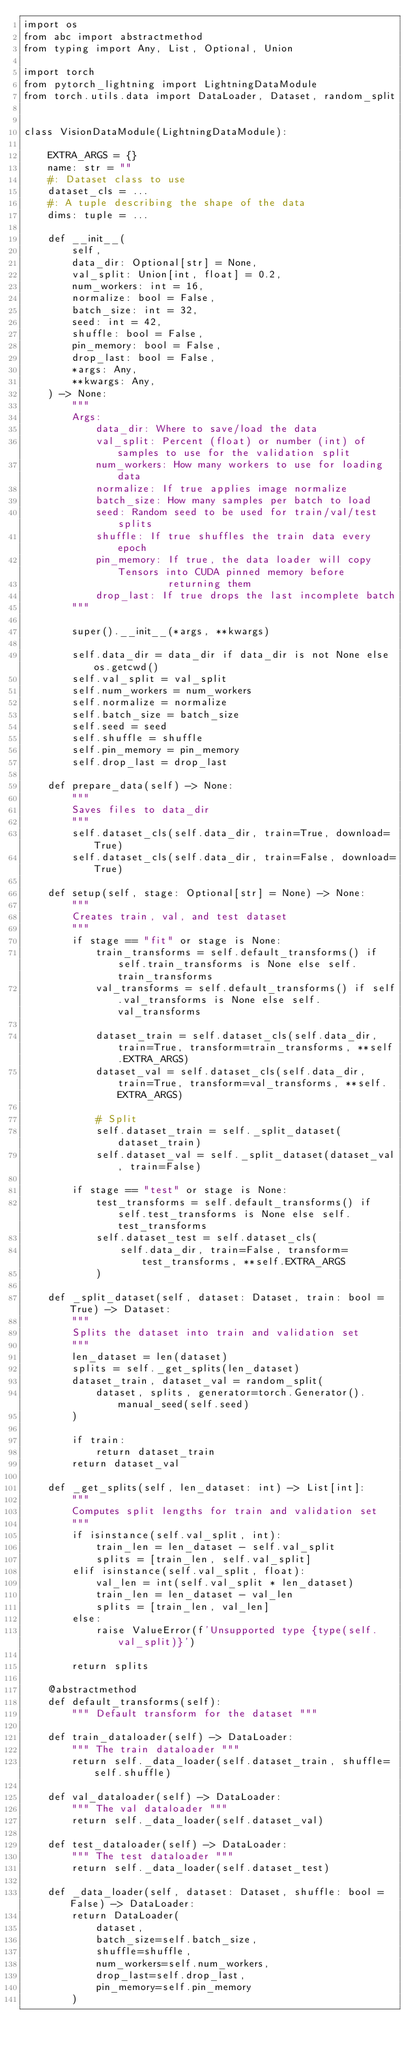Convert code to text. <code><loc_0><loc_0><loc_500><loc_500><_Python_>import os
from abc import abstractmethod
from typing import Any, List, Optional, Union

import torch
from pytorch_lightning import LightningDataModule
from torch.utils.data import DataLoader, Dataset, random_split


class VisionDataModule(LightningDataModule):

    EXTRA_ARGS = {}
    name: str = ""
    #: Dataset class to use
    dataset_cls = ...
    #: A tuple describing the shape of the data
    dims: tuple = ...

    def __init__(
        self,
        data_dir: Optional[str] = None,
        val_split: Union[int, float] = 0.2,
        num_workers: int = 16,
        normalize: bool = False,
        batch_size: int = 32,
        seed: int = 42,
        shuffle: bool = False,
        pin_memory: bool = False,
        drop_last: bool = False,
        *args: Any,
        **kwargs: Any,
    ) -> None:
        """
        Args:
            data_dir: Where to save/load the data
            val_split: Percent (float) or number (int) of samples to use for the validation split
            num_workers: How many workers to use for loading data
            normalize: If true applies image normalize
            batch_size: How many samples per batch to load
            seed: Random seed to be used for train/val/test splits
            shuffle: If true shuffles the train data every epoch
            pin_memory: If true, the data loader will copy Tensors into CUDA pinned memory before
                        returning them
            drop_last: If true drops the last incomplete batch
        """

        super().__init__(*args, **kwargs)

        self.data_dir = data_dir if data_dir is not None else os.getcwd()
        self.val_split = val_split
        self.num_workers = num_workers
        self.normalize = normalize
        self.batch_size = batch_size
        self.seed = seed
        self.shuffle = shuffle
        self.pin_memory = pin_memory
        self.drop_last = drop_last

    def prepare_data(self) -> None:
        """
        Saves files to data_dir
        """
        self.dataset_cls(self.data_dir, train=True, download=True)
        self.dataset_cls(self.data_dir, train=False, download=True)

    def setup(self, stage: Optional[str] = None) -> None:
        """
        Creates train, val, and test dataset
        """
        if stage == "fit" or stage is None:
            train_transforms = self.default_transforms() if self.train_transforms is None else self.train_transforms
            val_transforms = self.default_transforms() if self.val_transforms is None else self.val_transforms

            dataset_train = self.dataset_cls(self.data_dir, train=True, transform=train_transforms, **self.EXTRA_ARGS)
            dataset_val = self.dataset_cls(self.data_dir, train=True, transform=val_transforms, **self.EXTRA_ARGS)

            # Split
            self.dataset_train = self._split_dataset(dataset_train)
            self.dataset_val = self._split_dataset(dataset_val, train=False)

        if stage == "test" or stage is None:
            test_transforms = self.default_transforms() if self.test_transforms is None else self.test_transforms
            self.dataset_test = self.dataset_cls(
                self.data_dir, train=False, transform=test_transforms, **self.EXTRA_ARGS
            )

    def _split_dataset(self, dataset: Dataset, train: bool = True) -> Dataset:
        """
        Splits the dataset into train and validation set
        """
        len_dataset = len(dataset)
        splits = self._get_splits(len_dataset)
        dataset_train, dataset_val = random_split(
            dataset, splits, generator=torch.Generator().manual_seed(self.seed)
        )

        if train:
            return dataset_train
        return dataset_val

    def _get_splits(self, len_dataset: int) -> List[int]:
        """
        Computes split lengths for train and validation set
        """
        if isinstance(self.val_split, int):
            train_len = len_dataset - self.val_split
            splits = [train_len, self.val_split]
        elif isinstance(self.val_split, float):
            val_len = int(self.val_split * len_dataset)
            train_len = len_dataset - val_len
            splits = [train_len, val_len]
        else:
            raise ValueError(f'Unsupported type {type(self.val_split)}')

        return splits

    @abstractmethod
    def default_transforms(self):
        """ Default transform for the dataset """

    def train_dataloader(self) -> DataLoader:
        """ The train dataloader """
        return self._data_loader(self.dataset_train, shuffle=self.shuffle)

    def val_dataloader(self) -> DataLoader:
        """ The val dataloader """
        return self._data_loader(self.dataset_val)

    def test_dataloader(self) -> DataLoader:
        """ The test dataloader """
        return self._data_loader(self.dataset_test)

    def _data_loader(self, dataset: Dataset, shuffle: bool = False) -> DataLoader:
        return DataLoader(
            dataset,
            batch_size=self.batch_size,
            shuffle=shuffle,
            num_workers=self.num_workers,
            drop_last=self.drop_last,
            pin_memory=self.pin_memory
        )
</code> 